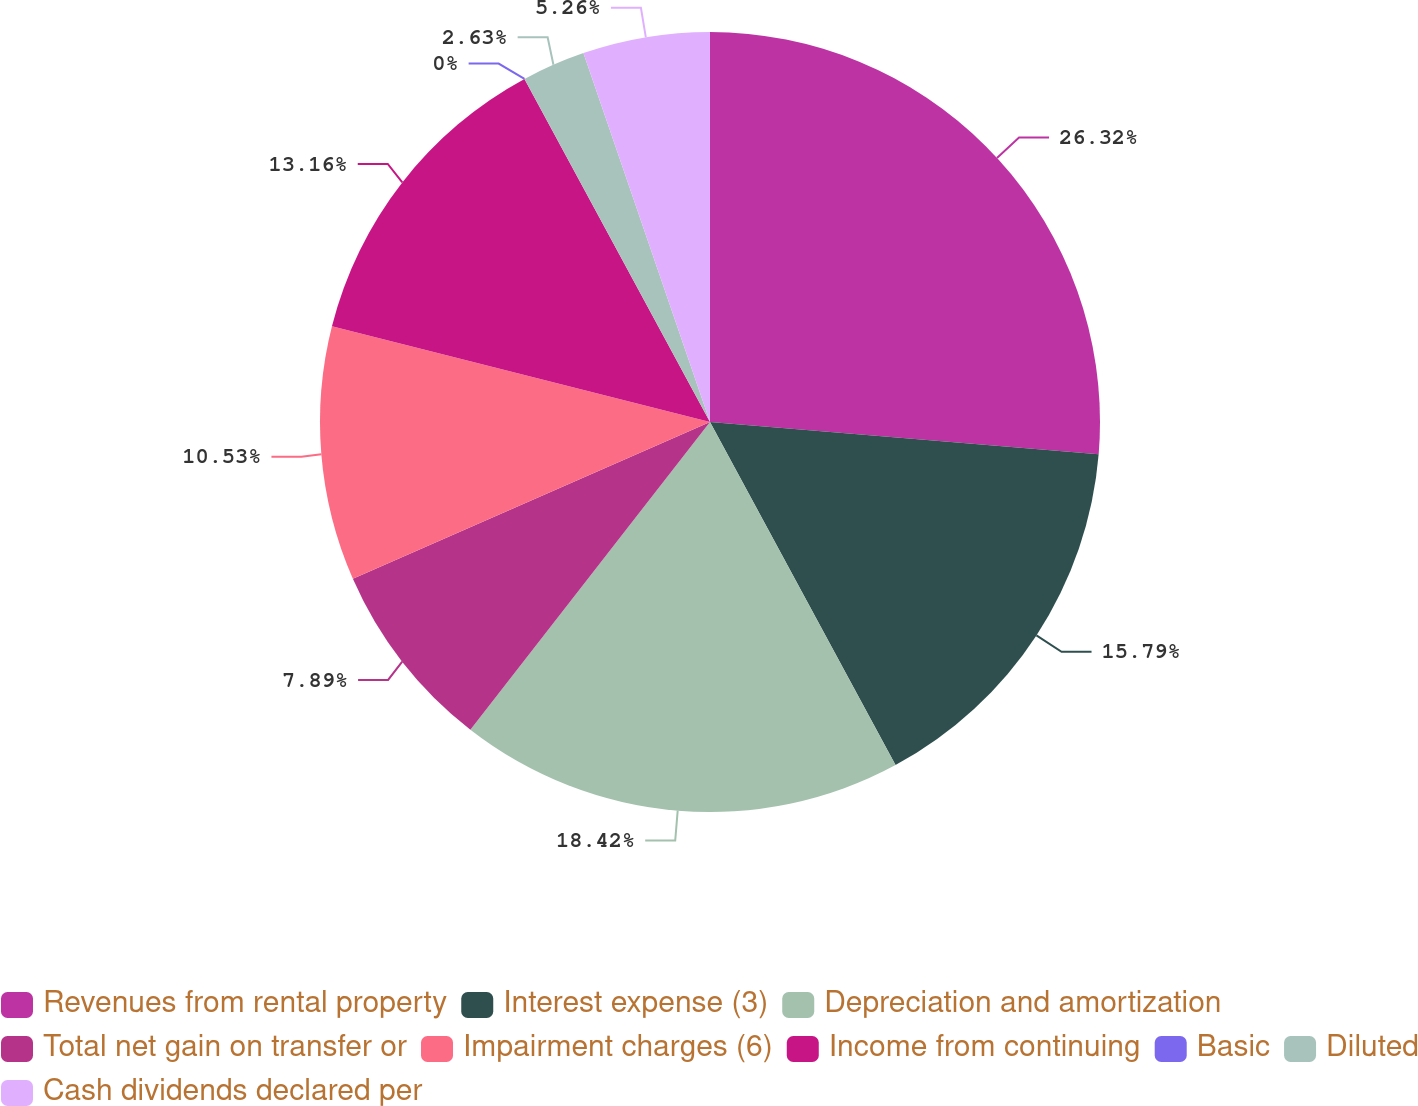<chart> <loc_0><loc_0><loc_500><loc_500><pie_chart><fcel>Revenues from rental property<fcel>Interest expense (3)<fcel>Depreciation and amortization<fcel>Total net gain on transfer or<fcel>Impairment charges (6)<fcel>Income from continuing<fcel>Basic<fcel>Diluted<fcel>Cash dividends declared per<nl><fcel>26.32%<fcel>15.79%<fcel>18.42%<fcel>7.89%<fcel>10.53%<fcel>13.16%<fcel>0.0%<fcel>2.63%<fcel>5.26%<nl></chart> 